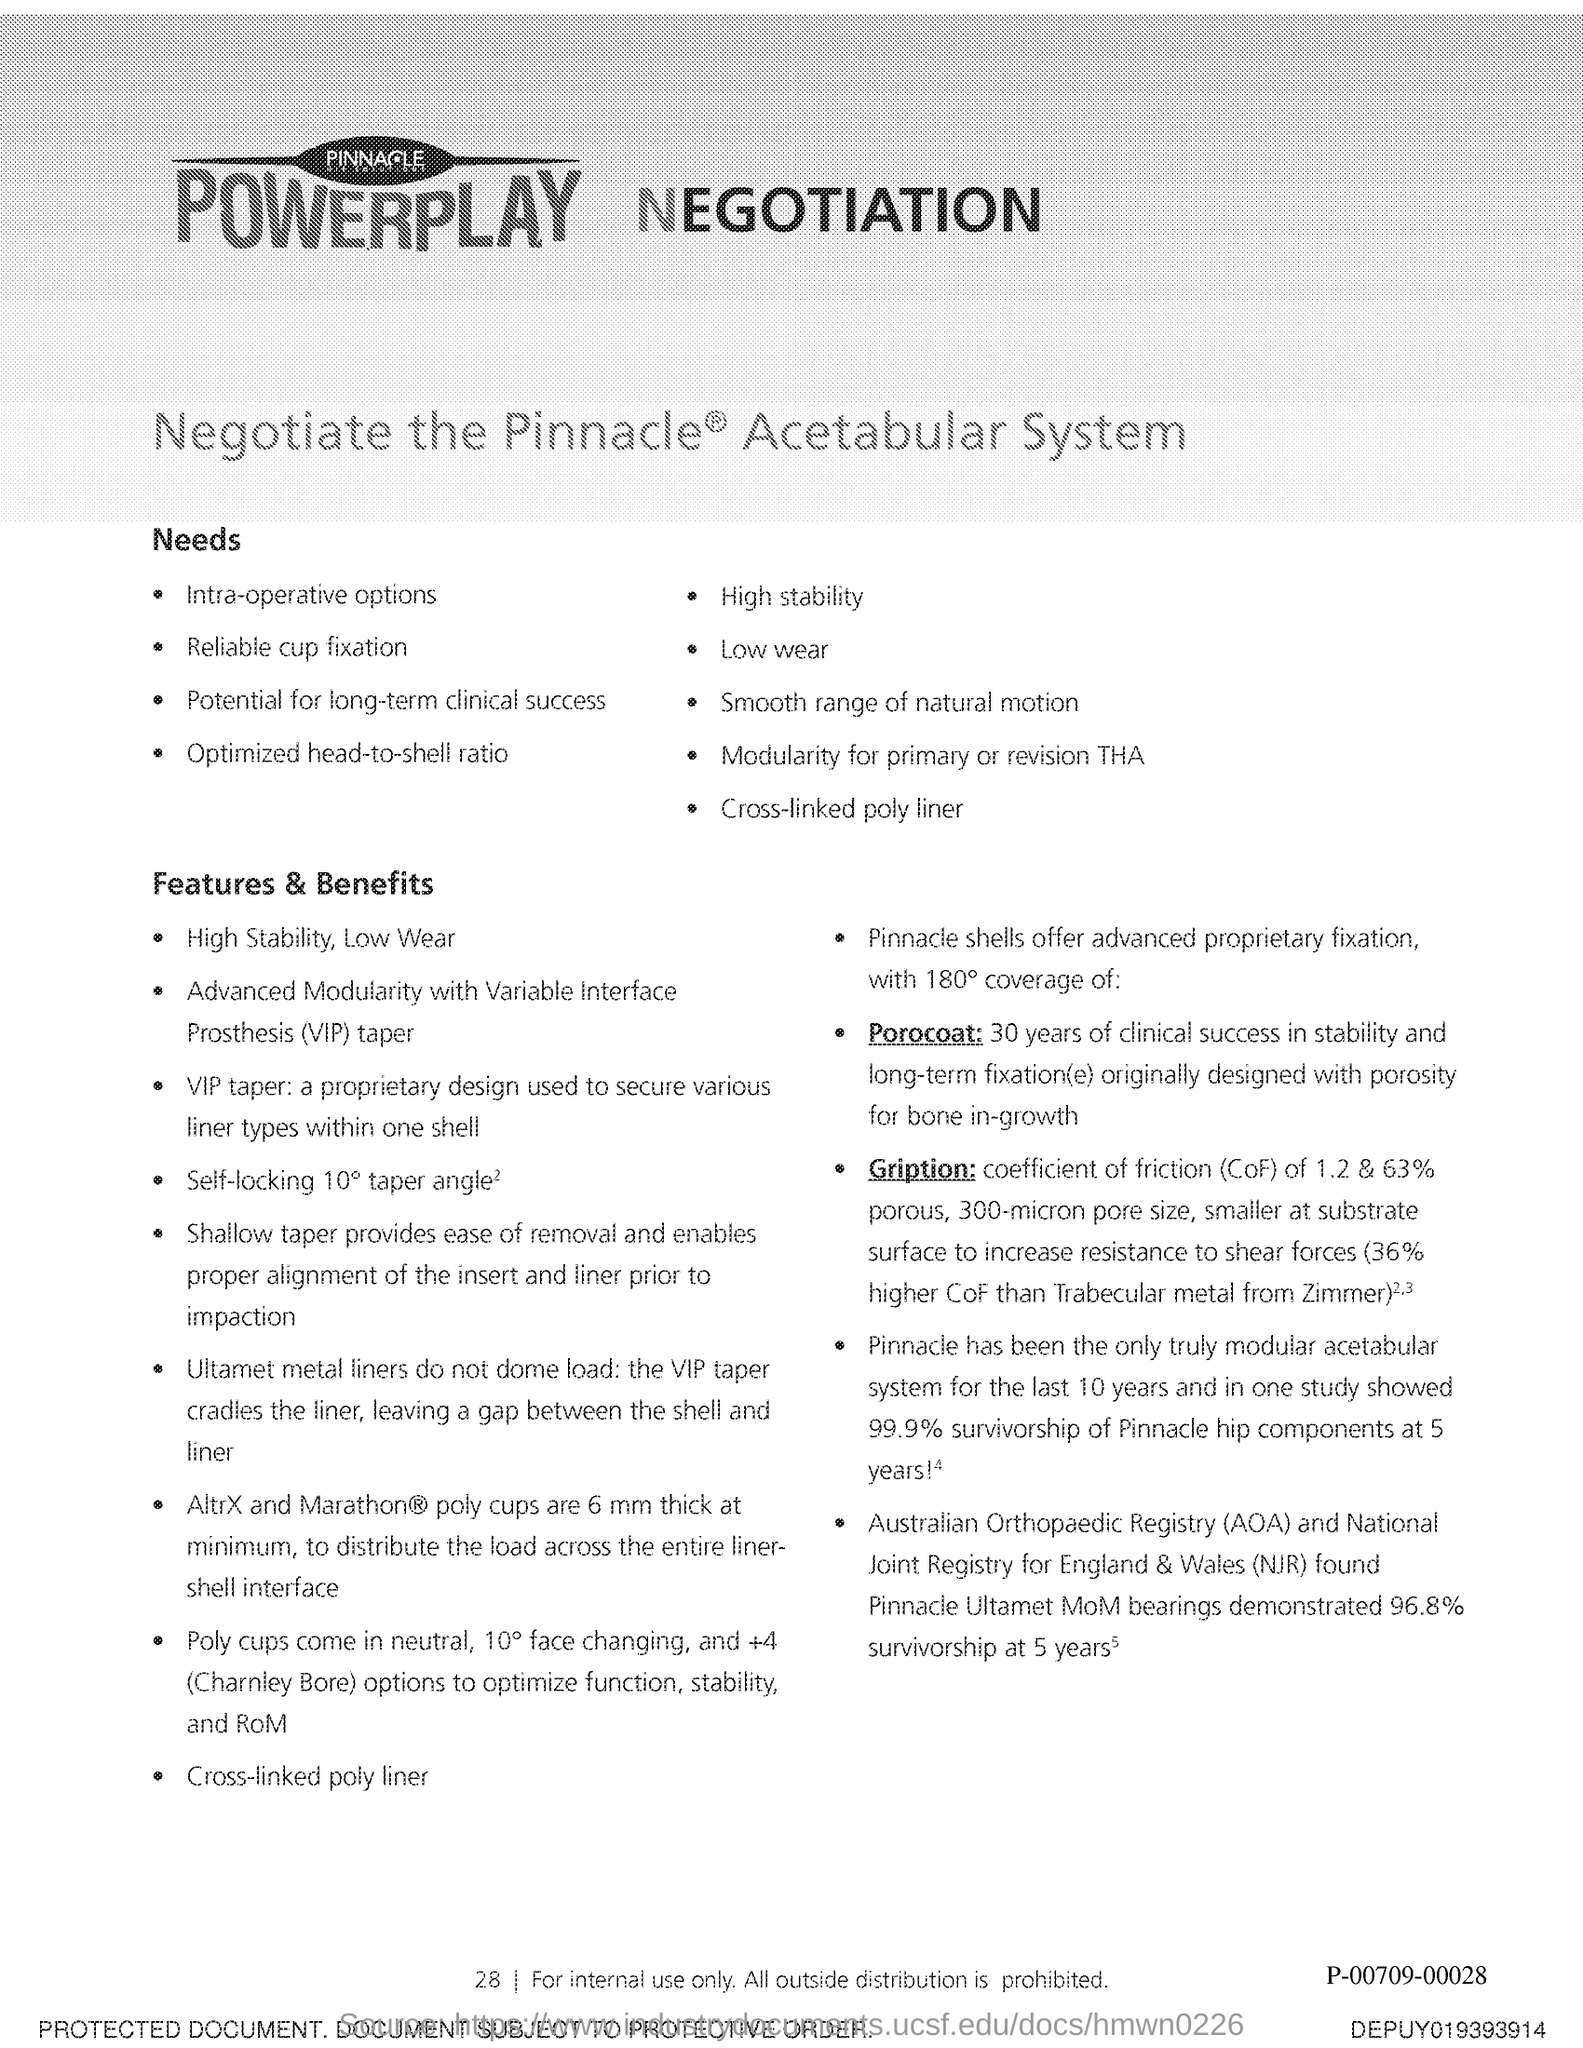Give some essential details in this illustration. The page number is 28," declared the speaker. 